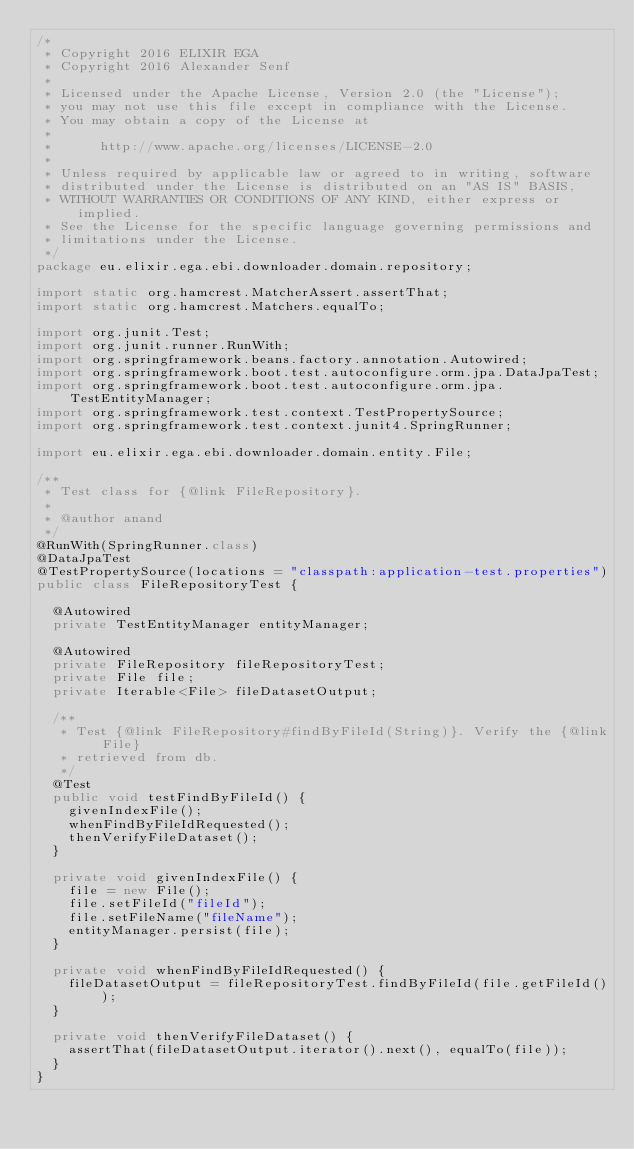<code> <loc_0><loc_0><loc_500><loc_500><_Java_>/*
 * Copyright 2016 ELIXIR EGA
 * Copyright 2016 Alexander Senf
 *
 * Licensed under the Apache License, Version 2.0 (the "License");
 * you may not use this file except in compliance with the License.
 * You may obtain a copy of the License at
 *
 *      http://www.apache.org/licenses/LICENSE-2.0
 *
 * Unless required by applicable law or agreed to in writing, software
 * distributed under the License is distributed on an "AS IS" BASIS,
 * WITHOUT WARRANTIES OR CONDITIONS OF ANY KIND, either express or implied.
 * See the License for the specific language governing permissions and
 * limitations under the License.
 */
package eu.elixir.ega.ebi.downloader.domain.repository;

import static org.hamcrest.MatcherAssert.assertThat;
import static org.hamcrest.Matchers.equalTo;

import org.junit.Test;
import org.junit.runner.RunWith;
import org.springframework.beans.factory.annotation.Autowired;
import org.springframework.boot.test.autoconfigure.orm.jpa.DataJpaTest;
import org.springframework.boot.test.autoconfigure.orm.jpa.TestEntityManager;
import org.springframework.test.context.TestPropertySource;
import org.springframework.test.context.junit4.SpringRunner;

import eu.elixir.ega.ebi.downloader.domain.entity.File;

/**
 * Test class for {@link FileRepository}.
 * 
 * @author anand
 */
@RunWith(SpringRunner.class)
@DataJpaTest
@TestPropertySource(locations = "classpath:application-test.properties")
public class FileRepositoryTest {

	@Autowired
	private TestEntityManager entityManager;

	@Autowired
	private FileRepository fileRepositoryTest;
	private File file;
	private Iterable<File> fileDatasetOutput;

	/**
	 * Test {@link FileRepository#findByFileId(String)}. Verify the {@link File}
	 * retrieved from db.
	 */
	@Test
	public void testFindByFileId() {
		givenIndexFile();
		whenFindByFileIdRequested();
		thenVerifyFileDataset();
	}

	private void givenIndexFile() {
		file = new File();
		file.setFileId("fileId");
		file.setFileName("fileName");
		entityManager.persist(file);
	}

	private void whenFindByFileIdRequested() {
		fileDatasetOutput = fileRepositoryTest.findByFileId(file.getFileId());
	}

	private void thenVerifyFileDataset() {
		assertThat(fileDatasetOutput.iterator().next(), equalTo(file));
	}
}
</code> 